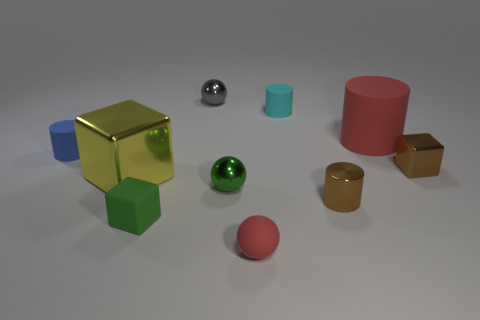Subtract all tiny rubber spheres. How many spheres are left? 2 Subtract 0 brown spheres. How many objects are left? 10 Subtract all spheres. How many objects are left? 7 Subtract 1 cylinders. How many cylinders are left? 3 Subtract all blue spheres. Subtract all green cylinders. How many spheres are left? 3 Subtract all blue spheres. How many blue blocks are left? 0 Subtract all metal balls. Subtract all large shiny blocks. How many objects are left? 7 Add 7 small brown shiny cylinders. How many small brown shiny cylinders are left? 8 Add 6 tiny balls. How many tiny balls exist? 9 Subtract all blue cylinders. How many cylinders are left? 3 